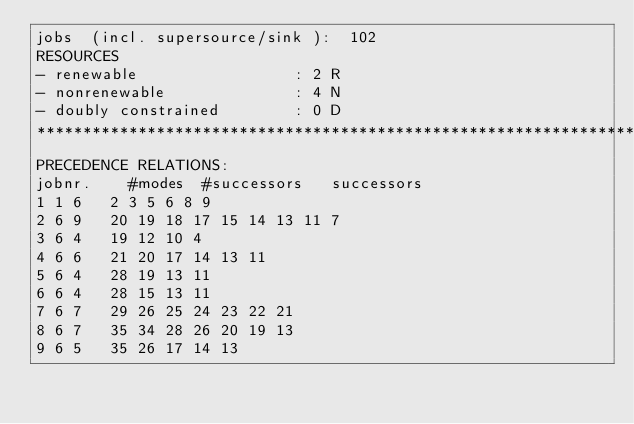Convert code to text. <code><loc_0><loc_0><loc_500><loc_500><_ObjectiveC_>jobs  (incl. supersource/sink ):	102
RESOURCES
- renewable                 : 2 R
- nonrenewable              : 4 N
- doubly constrained        : 0 D
************************************************************************
PRECEDENCE RELATIONS:
jobnr.    #modes  #successors   successors
1	1	6		2 3 5 6 8 9 
2	6	9		20 19 18 17 15 14 13 11 7 
3	6	4		19 12 10 4 
4	6	6		21 20 17 14 13 11 
5	6	4		28 19 13 11 
6	6	4		28 15 13 11 
7	6	7		29 26 25 24 23 22 21 
8	6	7		35 34 28 26 20 19 13 
9	6	5		35 26 17 14 13 </code> 